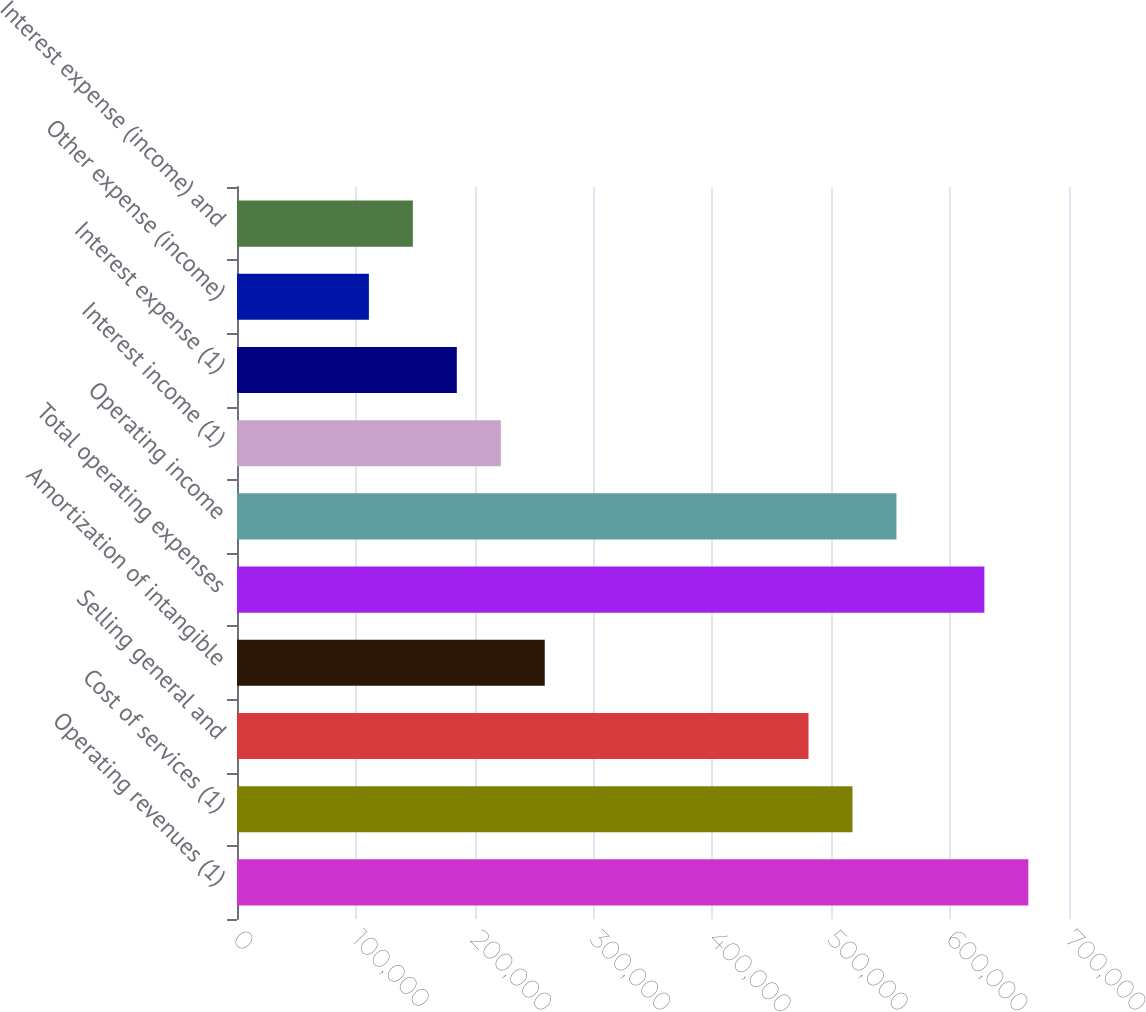<chart> <loc_0><loc_0><loc_500><loc_500><bar_chart><fcel>Operating revenues (1)<fcel>Cost of services (1)<fcel>Selling general and<fcel>Amortization of intangible<fcel>Total operating expenses<fcel>Operating income<fcel>Interest income (1)<fcel>Interest expense (1)<fcel>Other expense (income)<fcel>Interest expense (income) and<nl><fcel>665794<fcel>517840<fcel>480851<fcel>258920<fcel>628805<fcel>554828<fcel>221932<fcel>184943<fcel>110966<fcel>147955<nl></chart> 